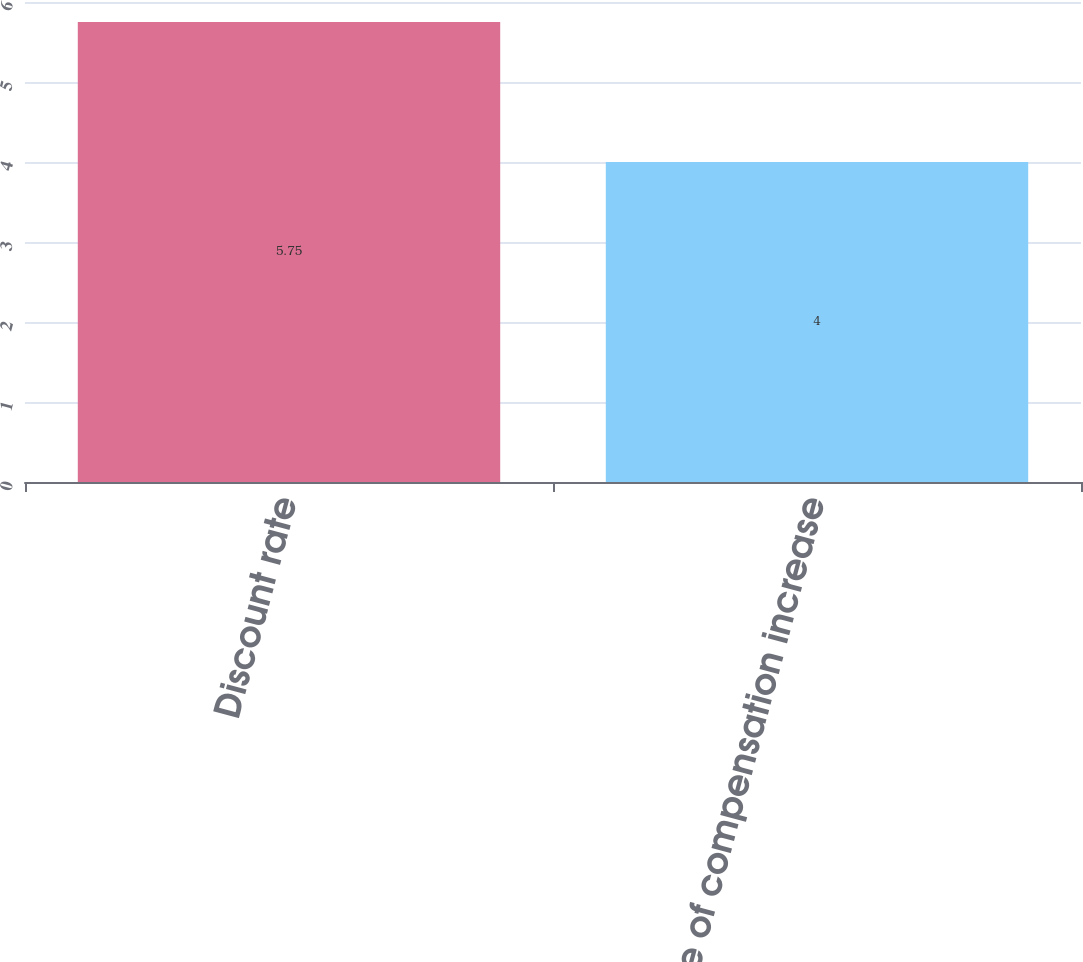Convert chart to OTSL. <chart><loc_0><loc_0><loc_500><loc_500><bar_chart><fcel>Discount rate<fcel>Rate of compensation increase<nl><fcel>5.75<fcel>4<nl></chart> 